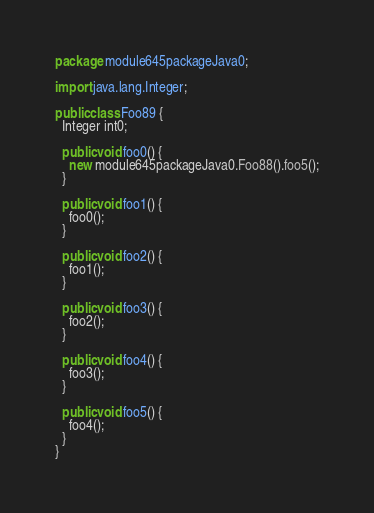Convert code to text. <code><loc_0><loc_0><loc_500><loc_500><_Java_>package module645packageJava0;

import java.lang.Integer;

public class Foo89 {
  Integer int0;

  public void foo0() {
    new module645packageJava0.Foo88().foo5();
  }

  public void foo1() {
    foo0();
  }

  public void foo2() {
    foo1();
  }

  public void foo3() {
    foo2();
  }

  public void foo4() {
    foo3();
  }

  public void foo5() {
    foo4();
  }
}
</code> 